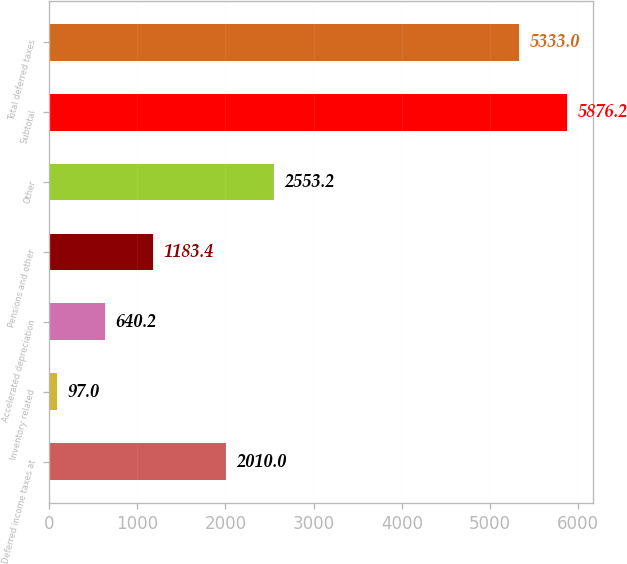Convert chart to OTSL. <chart><loc_0><loc_0><loc_500><loc_500><bar_chart><fcel>Deferred income taxes at<fcel>Inventory related<fcel>Accelerated depreciation<fcel>Pensions and other<fcel>Other<fcel>Subtotal<fcel>Total deferred taxes<nl><fcel>2010<fcel>97<fcel>640.2<fcel>1183.4<fcel>2553.2<fcel>5876.2<fcel>5333<nl></chart> 